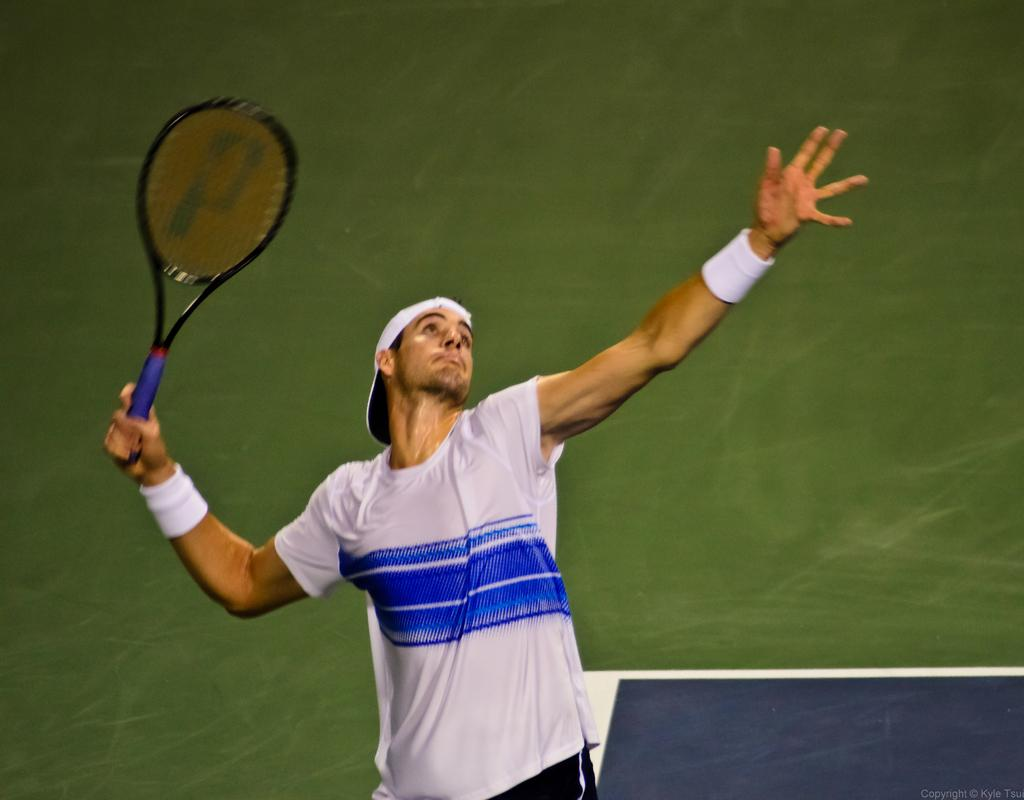Who is present in the image? There is a man in the image. What is the man wearing on his upper body? The man is wearing a white t-shirt. What is the man wearing on his head? The man is wearing a red cap. What object is the man holding in the image? The man is holding a tennis racket. What type of terrain is visible in the image? The image shows grassland. What type of fork can be seen in the man's hand in the image? There is no fork present in the image; the man is holding a tennis racket. In which direction is the man facing in the image? The image does not provide information about the direction the man is facing. 